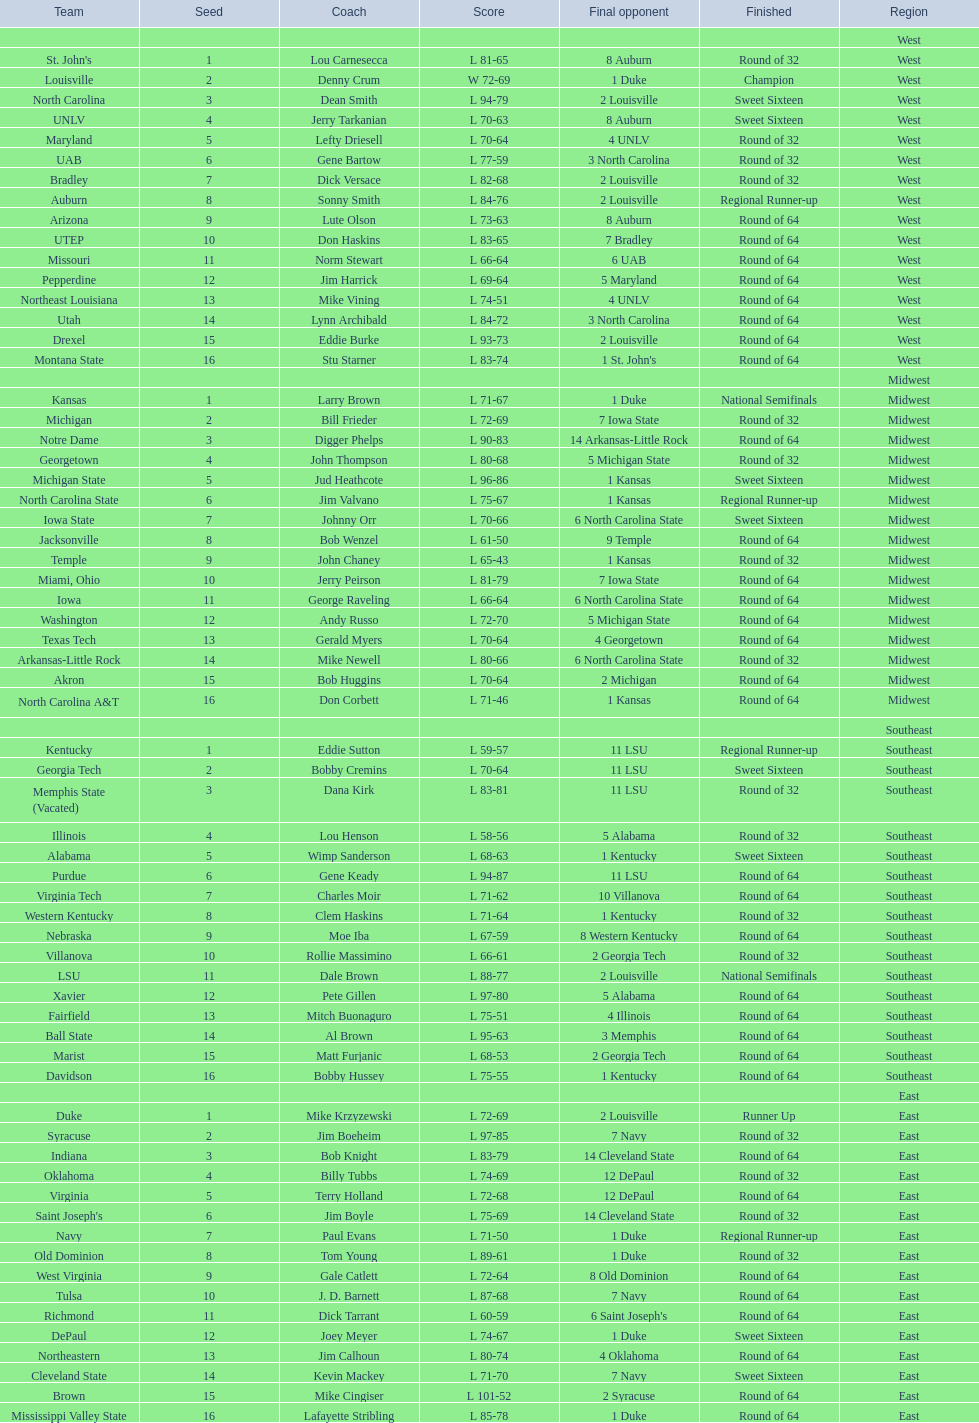Can you give me this table as a dict? {'header': ['Team', 'Seed', 'Coach', 'Score', 'Final opponent', 'Finished', 'Region'], 'rows': [['', '', '', '', '', '', 'West'], ["St. John's", '1', 'Lou Carnesecca', 'L 81-65', '8 Auburn', 'Round of 32', 'West'], ['Louisville', '2', 'Denny Crum', 'W 72-69', '1 Duke', 'Champion', 'West'], ['North Carolina', '3', 'Dean Smith', 'L 94-79', '2 Louisville', 'Sweet Sixteen', 'West'], ['UNLV', '4', 'Jerry Tarkanian', 'L 70-63', '8 Auburn', 'Sweet Sixteen', 'West'], ['Maryland', '5', 'Lefty Driesell', 'L 70-64', '4 UNLV', 'Round of 32', 'West'], ['UAB', '6', 'Gene Bartow', 'L 77-59', '3 North Carolina', 'Round of 32', 'West'], ['Bradley', '7', 'Dick Versace', 'L 82-68', '2 Louisville', 'Round of 32', 'West'], ['Auburn', '8', 'Sonny Smith', 'L 84-76', '2 Louisville', 'Regional Runner-up', 'West'], ['Arizona', '9', 'Lute Olson', 'L 73-63', '8 Auburn', 'Round of 64', 'West'], ['UTEP', '10', 'Don Haskins', 'L 83-65', '7 Bradley', 'Round of 64', 'West'], ['Missouri', '11', 'Norm Stewart', 'L 66-64', '6 UAB', 'Round of 64', 'West'], ['Pepperdine', '12', 'Jim Harrick', 'L 69-64', '5 Maryland', 'Round of 64', 'West'], ['Northeast Louisiana', '13', 'Mike Vining', 'L 74-51', '4 UNLV', 'Round of 64', 'West'], ['Utah', '14', 'Lynn Archibald', 'L 84-72', '3 North Carolina', 'Round of 64', 'West'], ['Drexel', '15', 'Eddie Burke', 'L 93-73', '2 Louisville', 'Round of 64', 'West'], ['Montana State', '16', 'Stu Starner', 'L 83-74', "1 St. John's", 'Round of 64', 'West'], ['', '', '', '', '', '', 'Midwest'], ['Kansas', '1', 'Larry Brown', 'L 71-67', '1 Duke', 'National Semifinals', 'Midwest'], ['Michigan', '2', 'Bill Frieder', 'L 72-69', '7 Iowa State', 'Round of 32', 'Midwest'], ['Notre Dame', '3', 'Digger Phelps', 'L 90-83', '14 Arkansas-Little Rock', 'Round of 64', 'Midwest'], ['Georgetown', '4', 'John Thompson', 'L 80-68', '5 Michigan State', 'Round of 32', 'Midwest'], ['Michigan State', '5', 'Jud Heathcote', 'L 96-86', '1 Kansas', 'Sweet Sixteen', 'Midwest'], ['North Carolina State', '6', 'Jim Valvano', 'L 75-67', '1 Kansas', 'Regional Runner-up', 'Midwest'], ['Iowa State', '7', 'Johnny Orr', 'L 70-66', '6 North Carolina State', 'Sweet Sixteen', 'Midwest'], ['Jacksonville', '8', 'Bob Wenzel', 'L 61-50', '9 Temple', 'Round of 64', 'Midwest'], ['Temple', '9', 'John Chaney', 'L 65-43', '1 Kansas', 'Round of 32', 'Midwest'], ['Miami, Ohio', '10', 'Jerry Peirson', 'L 81-79', '7 Iowa State', 'Round of 64', 'Midwest'], ['Iowa', '11', 'George Raveling', 'L 66-64', '6 North Carolina State', 'Round of 64', 'Midwest'], ['Washington', '12', 'Andy Russo', 'L 72-70', '5 Michigan State', 'Round of 64', 'Midwest'], ['Texas Tech', '13', 'Gerald Myers', 'L 70-64', '4 Georgetown', 'Round of 64', 'Midwest'], ['Arkansas-Little Rock', '14', 'Mike Newell', 'L 80-66', '6 North Carolina State', 'Round of 32', 'Midwest'], ['Akron', '15', 'Bob Huggins', 'L 70-64', '2 Michigan', 'Round of 64', 'Midwest'], ['North Carolina A&T', '16', 'Don Corbett', 'L 71-46', '1 Kansas', 'Round of 64', 'Midwest'], ['', '', '', '', '', '', 'Southeast'], ['Kentucky', '1', 'Eddie Sutton', 'L 59-57', '11 LSU', 'Regional Runner-up', 'Southeast'], ['Georgia Tech', '2', 'Bobby Cremins', 'L 70-64', '11 LSU', 'Sweet Sixteen', 'Southeast'], ['Memphis State (Vacated)', '3', 'Dana Kirk', 'L 83-81', '11 LSU', 'Round of 32', 'Southeast'], ['Illinois', '4', 'Lou Henson', 'L 58-56', '5 Alabama', 'Round of 32', 'Southeast'], ['Alabama', '5', 'Wimp Sanderson', 'L 68-63', '1 Kentucky', 'Sweet Sixteen', 'Southeast'], ['Purdue', '6', 'Gene Keady', 'L 94-87', '11 LSU', 'Round of 64', 'Southeast'], ['Virginia Tech', '7', 'Charles Moir', 'L 71-62', '10 Villanova', 'Round of 64', 'Southeast'], ['Western Kentucky', '8', 'Clem Haskins', 'L 71-64', '1 Kentucky', 'Round of 32', 'Southeast'], ['Nebraska', '9', 'Moe Iba', 'L 67-59', '8 Western Kentucky', 'Round of 64', 'Southeast'], ['Villanova', '10', 'Rollie Massimino', 'L 66-61', '2 Georgia Tech', 'Round of 32', 'Southeast'], ['LSU', '11', 'Dale Brown', 'L 88-77', '2 Louisville', 'National Semifinals', 'Southeast'], ['Xavier', '12', 'Pete Gillen', 'L 97-80', '5 Alabama', 'Round of 64', 'Southeast'], ['Fairfield', '13', 'Mitch Buonaguro', 'L 75-51', '4 Illinois', 'Round of 64', 'Southeast'], ['Ball State', '14', 'Al Brown', 'L 95-63', '3 Memphis', 'Round of 64', 'Southeast'], ['Marist', '15', 'Matt Furjanic', 'L 68-53', '2 Georgia Tech', 'Round of 64', 'Southeast'], ['Davidson', '16', 'Bobby Hussey', 'L 75-55', '1 Kentucky', 'Round of 64', 'Southeast'], ['', '', '', '', '', '', 'East'], ['Duke', '1', 'Mike Krzyzewski', 'L 72-69', '2 Louisville', 'Runner Up', 'East'], ['Syracuse', '2', 'Jim Boeheim', 'L 97-85', '7 Navy', 'Round of 32', 'East'], ['Indiana', '3', 'Bob Knight', 'L 83-79', '14 Cleveland State', 'Round of 64', 'East'], ['Oklahoma', '4', 'Billy Tubbs', 'L 74-69', '12 DePaul', 'Round of 32', 'East'], ['Virginia', '5', 'Terry Holland', 'L 72-68', '12 DePaul', 'Round of 64', 'East'], ["Saint Joseph's", '6', 'Jim Boyle', 'L 75-69', '14 Cleveland State', 'Round of 32', 'East'], ['Navy', '7', 'Paul Evans', 'L 71-50', '1 Duke', 'Regional Runner-up', 'East'], ['Old Dominion', '8', 'Tom Young', 'L 89-61', '1 Duke', 'Round of 32', 'East'], ['West Virginia', '9', 'Gale Catlett', 'L 72-64', '8 Old Dominion', 'Round of 64', 'East'], ['Tulsa', '10', 'J. D. Barnett', 'L 87-68', '7 Navy', 'Round of 64', 'East'], ['Richmond', '11', 'Dick Tarrant', 'L 60-59', "6 Saint Joseph's", 'Round of 64', 'East'], ['DePaul', '12', 'Joey Meyer', 'L 74-67', '1 Duke', 'Sweet Sixteen', 'East'], ['Northeastern', '13', 'Jim Calhoun', 'L 80-74', '4 Oklahoma', 'Round of 64', 'East'], ['Cleveland State', '14', 'Kevin Mackey', 'L 71-70', '7 Navy', 'Sweet Sixteen', 'East'], ['Brown', '15', 'Mike Cingiser', 'L 101-52', '2 Syracuse', 'Round of 64', 'East'], ['Mississippi Valley State', '16', 'Lafayette Stribling', 'L 85-78', '1 Duke', 'Round of 64', 'East']]} How many 1 seeds are there? 4. 